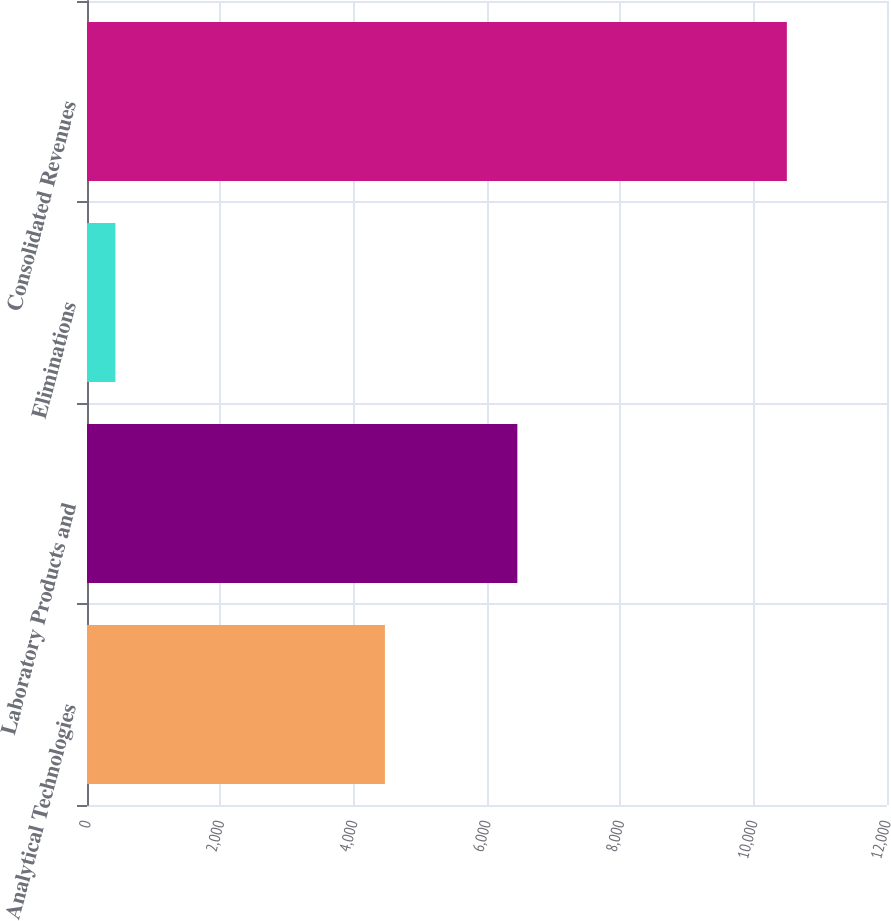Convert chart to OTSL. <chart><loc_0><loc_0><loc_500><loc_500><bar_chart><fcel>Analytical Technologies<fcel>Laboratory Products and<fcel>Eliminations<fcel>Consolidated Revenues<nl><fcel>4468.6<fcel>6455.2<fcel>425.8<fcel>10498<nl></chart> 